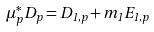Convert formula to latex. <formula><loc_0><loc_0><loc_500><loc_500>\mu _ { p } ^ { * } D _ { p } = D _ { 1 , p } + m _ { 1 } E _ { 1 , p }</formula> 